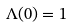<formula> <loc_0><loc_0><loc_500><loc_500>\Lambda ( 0 ) = 1 \,</formula> 